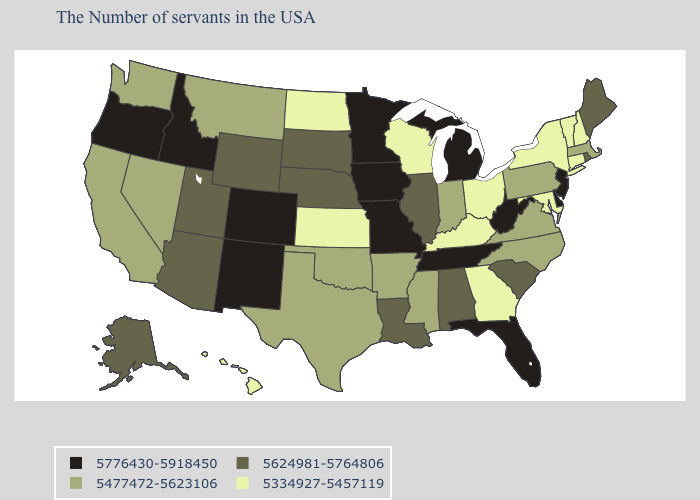What is the lowest value in states that border Colorado?
Be succinct. 5334927-5457119. Does West Virginia have the lowest value in the South?
Quick response, please. No. What is the value of North Carolina?
Quick response, please. 5477472-5623106. What is the value of Arizona?
Write a very short answer. 5624981-5764806. Which states hav the highest value in the South?
Give a very brief answer. Delaware, West Virginia, Florida, Tennessee. Name the states that have a value in the range 5776430-5918450?
Concise answer only. New Jersey, Delaware, West Virginia, Florida, Michigan, Tennessee, Missouri, Minnesota, Iowa, Colorado, New Mexico, Idaho, Oregon. Name the states that have a value in the range 5477472-5623106?
Answer briefly. Massachusetts, Pennsylvania, Virginia, North Carolina, Indiana, Mississippi, Arkansas, Oklahoma, Texas, Montana, Nevada, California, Washington. Name the states that have a value in the range 5776430-5918450?
Give a very brief answer. New Jersey, Delaware, West Virginia, Florida, Michigan, Tennessee, Missouri, Minnesota, Iowa, Colorado, New Mexico, Idaho, Oregon. How many symbols are there in the legend?
Give a very brief answer. 4. Name the states that have a value in the range 5624981-5764806?
Give a very brief answer. Maine, Rhode Island, South Carolina, Alabama, Illinois, Louisiana, Nebraska, South Dakota, Wyoming, Utah, Arizona, Alaska. Among the states that border Arkansas , which have the highest value?
Short answer required. Tennessee, Missouri. Name the states that have a value in the range 5477472-5623106?
Concise answer only. Massachusetts, Pennsylvania, Virginia, North Carolina, Indiana, Mississippi, Arkansas, Oklahoma, Texas, Montana, Nevada, California, Washington. Among the states that border Florida , does Alabama have the highest value?
Concise answer only. Yes. What is the value of Connecticut?
Keep it brief. 5334927-5457119. What is the value of New Mexico?
Short answer required. 5776430-5918450. 